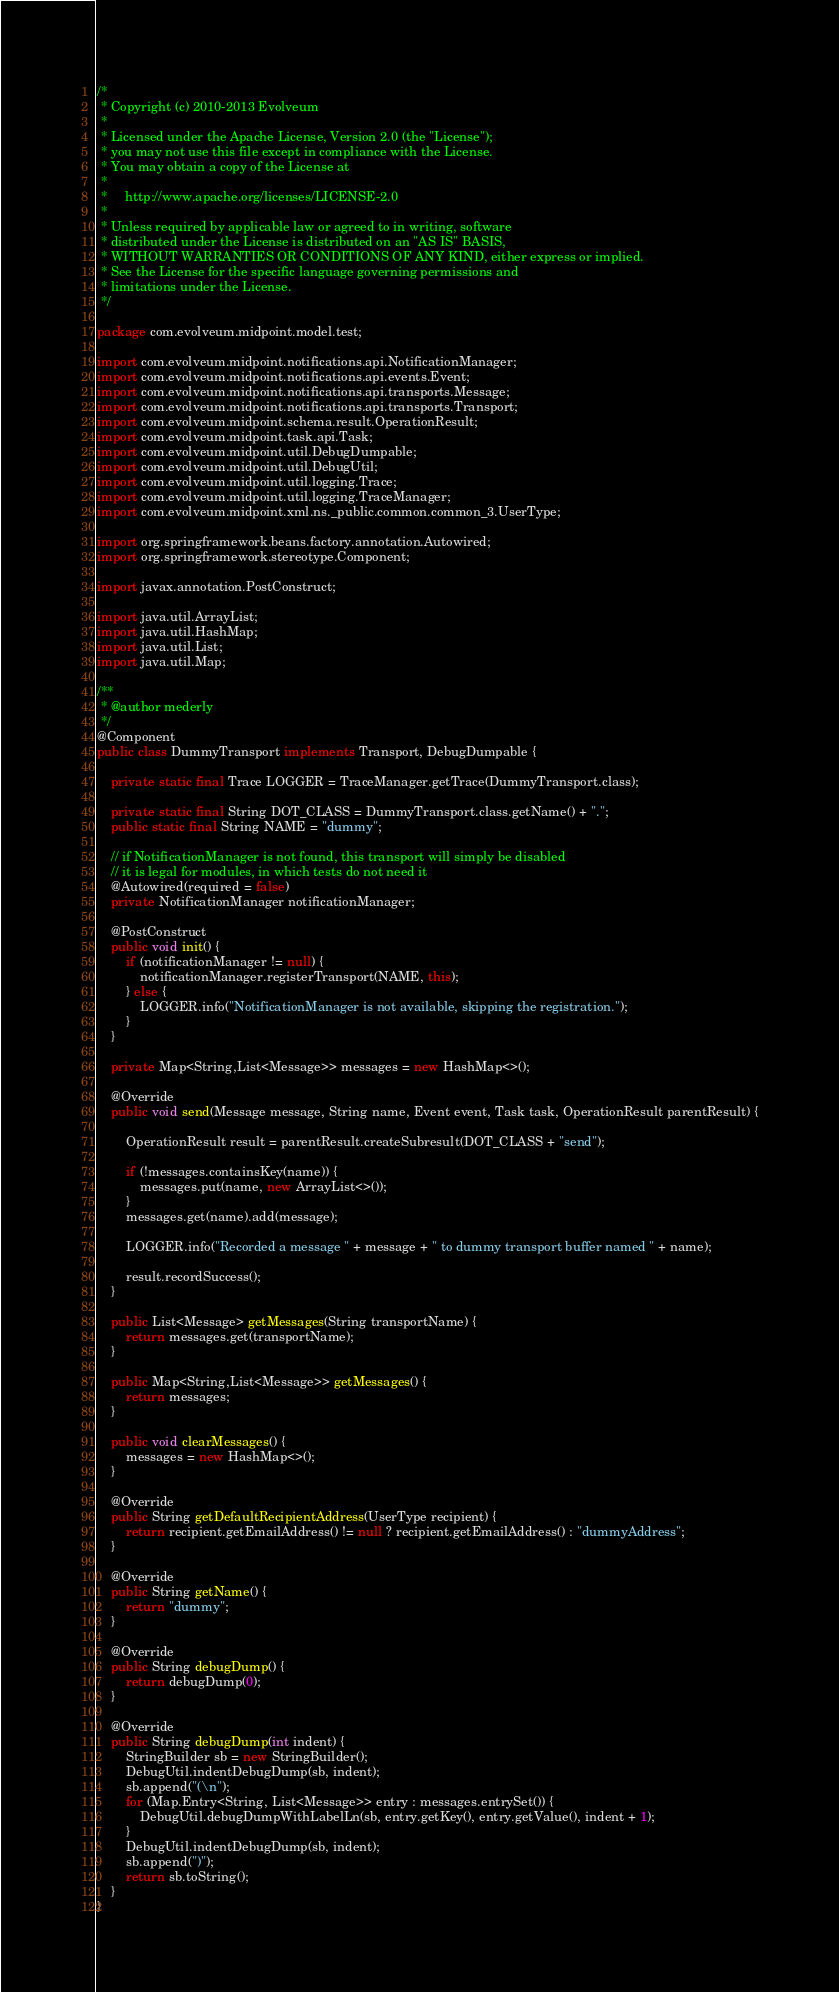Convert code to text. <code><loc_0><loc_0><loc_500><loc_500><_Java_>/*
 * Copyright (c) 2010-2013 Evolveum
 *
 * Licensed under the Apache License, Version 2.0 (the "License");
 * you may not use this file except in compliance with the License.
 * You may obtain a copy of the License at
 *
 *     http://www.apache.org/licenses/LICENSE-2.0
 *
 * Unless required by applicable law or agreed to in writing, software
 * distributed under the License is distributed on an "AS IS" BASIS,
 * WITHOUT WARRANTIES OR CONDITIONS OF ANY KIND, either express or implied.
 * See the License for the specific language governing permissions and
 * limitations under the License.
 */

package com.evolveum.midpoint.model.test;

import com.evolveum.midpoint.notifications.api.NotificationManager;
import com.evolveum.midpoint.notifications.api.events.Event;
import com.evolveum.midpoint.notifications.api.transports.Message;
import com.evolveum.midpoint.notifications.api.transports.Transport;
import com.evolveum.midpoint.schema.result.OperationResult;
import com.evolveum.midpoint.task.api.Task;
import com.evolveum.midpoint.util.DebugDumpable;
import com.evolveum.midpoint.util.DebugUtil;
import com.evolveum.midpoint.util.logging.Trace;
import com.evolveum.midpoint.util.logging.TraceManager;
import com.evolveum.midpoint.xml.ns._public.common.common_3.UserType;

import org.springframework.beans.factory.annotation.Autowired;
import org.springframework.stereotype.Component;

import javax.annotation.PostConstruct;

import java.util.ArrayList;
import java.util.HashMap;
import java.util.List;
import java.util.Map;

/**
 * @author mederly
 */
@Component
public class DummyTransport implements Transport, DebugDumpable {

    private static final Trace LOGGER = TraceManager.getTrace(DummyTransport.class);

    private static final String DOT_CLASS = DummyTransport.class.getName() + ".";
    public static final String NAME = "dummy";

    // if NotificationManager is not found, this transport will simply be disabled
    // it is legal for modules, in which tests do not need it
    @Autowired(required = false)
    private NotificationManager notificationManager;

    @PostConstruct
    public void init() {
        if (notificationManager != null) {
            notificationManager.registerTransport(NAME, this);
        } else {
            LOGGER.info("NotificationManager is not available, skipping the registration.");
        }
    }

    private Map<String,List<Message>> messages = new HashMap<>();

    @Override
    public void send(Message message, String name, Event event, Task task, OperationResult parentResult) {

        OperationResult result = parentResult.createSubresult(DOT_CLASS + "send");

        if (!messages.containsKey(name)) {
            messages.put(name, new ArrayList<>());
        }
        messages.get(name).add(message);

        LOGGER.info("Recorded a message " + message + " to dummy transport buffer named " + name);

        result.recordSuccess();
    }

    public List<Message> getMessages(String transportName) {
        return messages.get(transportName);
    }

    public Map<String,List<Message>> getMessages() {
    	return messages;
    }

    public void clearMessages() {
        messages = new HashMap<>();
    }

    @Override
    public String getDefaultRecipientAddress(UserType recipient) {
        return recipient.getEmailAddress() != null ? recipient.getEmailAddress() : "dummyAddress";
    }

    @Override
    public String getName() {
        return "dummy";
    }

	@Override
	public String debugDump() {
		return debugDump(0);
	}

	@Override
	public String debugDump(int indent) {
    	StringBuilder sb = new StringBuilder();
    	DebugUtil.indentDebugDump(sb, indent);
    	sb.append("(\n");
		for (Map.Entry<String, List<Message>> entry : messages.entrySet()) {
			DebugUtil.debugDumpWithLabelLn(sb, entry.getKey(), entry.getValue(), indent + 1);
		}
		DebugUtil.indentDebugDump(sb, indent);
		sb.append(")");
		return sb.toString();
	}
}
</code> 